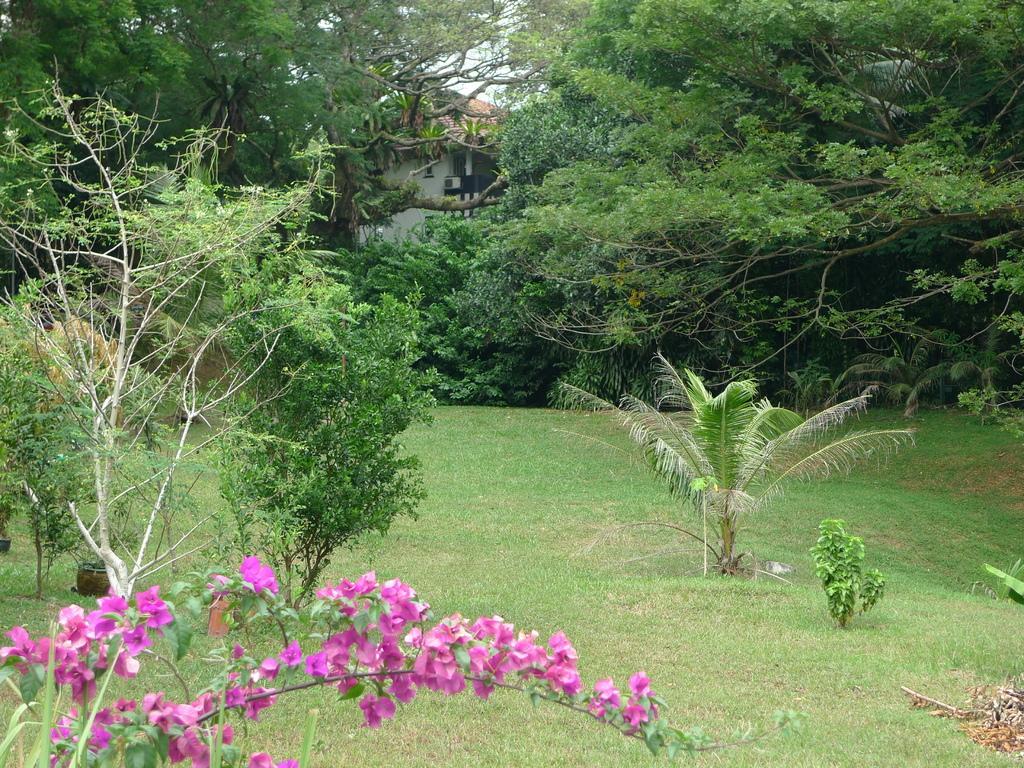Please provide a concise description of this image. In the picture we can see a garden with a grass surface on it, we can see some plants and in the background, we can see trees and from it we can see some part of a house. 